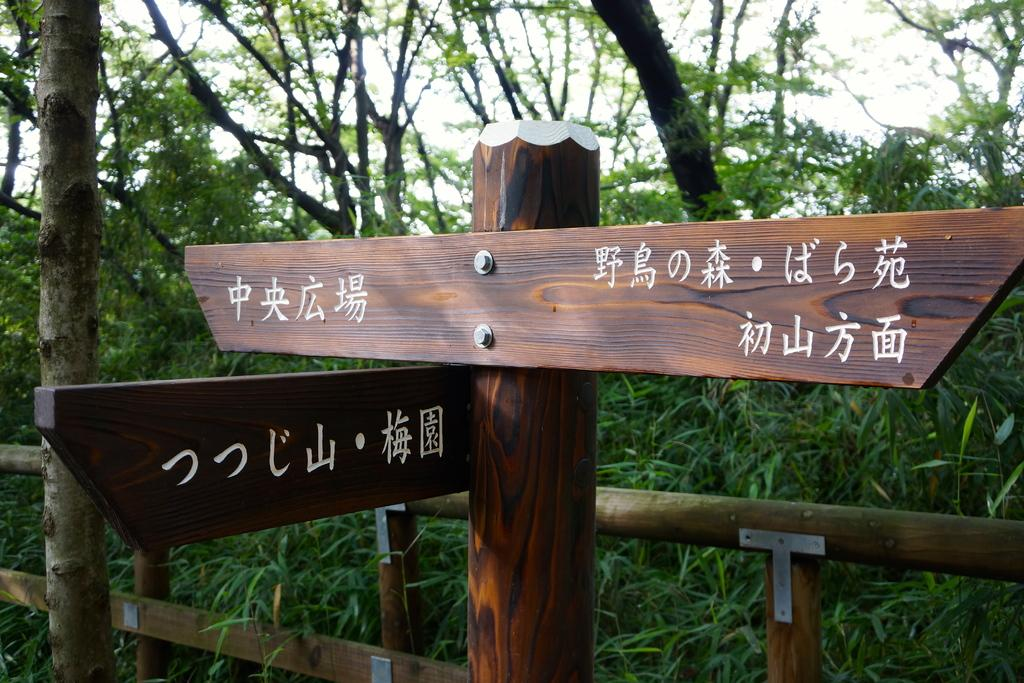What is located in the foreground of the image? There are boards with text in the foreground of the image. How are the boards positioned in the image? The boards are placed on a pole. What can be seen in the background of the image? There is a barricade and a group of trees in the background of the image. What is visible above the trees and barricade in the image? A: The sky is visible in the background of the image. What type of leather is being used to make the wine in the image? There is no leather or wine present in the image; it features boards with text on a pole and a barricade with trees in the background. What type of farm can be seen in the background of the image? There is no farm present in the image; it features a barricade and a group of trees in the background. 